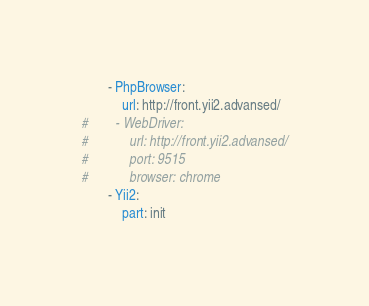<code> <loc_0><loc_0><loc_500><loc_500><_YAML_>        - PhpBrowser:
            url: http://front.yii2.advansed/
#        - WebDriver:
#            url: http://front.yii2.advansed/
#            port: 9515
#            browser: chrome
        - Yii2:
            part: init
</code> 